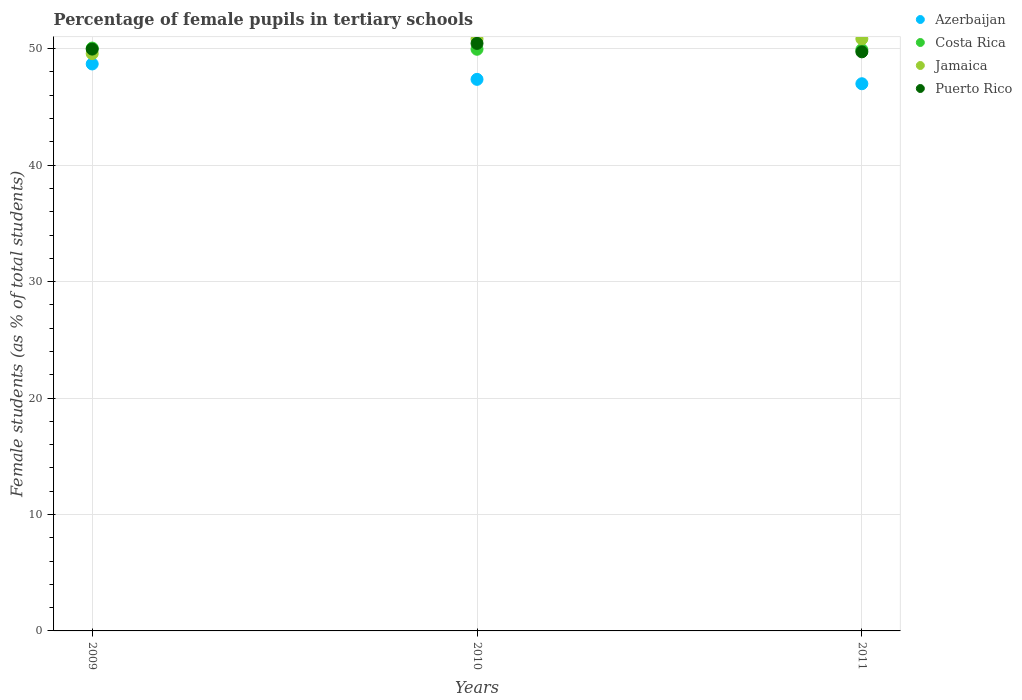What is the percentage of female pupils in tertiary schools in Costa Rica in 2011?
Your answer should be very brief. 49.91. Across all years, what is the maximum percentage of female pupils in tertiary schools in Puerto Rico?
Keep it short and to the point. 50.45. Across all years, what is the minimum percentage of female pupils in tertiary schools in Azerbaijan?
Offer a very short reply. 46.99. In which year was the percentage of female pupils in tertiary schools in Costa Rica maximum?
Your answer should be compact. 2009. In which year was the percentage of female pupils in tertiary schools in Puerto Rico minimum?
Provide a short and direct response. 2011. What is the total percentage of female pupils in tertiary schools in Costa Rica in the graph?
Make the answer very short. 149.92. What is the difference between the percentage of female pupils in tertiary schools in Azerbaijan in 2009 and that in 2010?
Ensure brevity in your answer.  1.32. What is the difference between the percentage of female pupils in tertiary schools in Azerbaijan in 2011 and the percentage of female pupils in tertiary schools in Costa Rica in 2009?
Make the answer very short. -3.06. What is the average percentage of female pupils in tertiary schools in Costa Rica per year?
Your answer should be very brief. 49.97. In the year 2010, what is the difference between the percentage of female pupils in tertiary schools in Azerbaijan and percentage of female pupils in tertiary schools in Jamaica?
Make the answer very short. -3.47. What is the ratio of the percentage of female pupils in tertiary schools in Puerto Rico in 2010 to that in 2011?
Keep it short and to the point. 1.01. Is the percentage of female pupils in tertiary schools in Jamaica in 2009 less than that in 2011?
Your answer should be compact. Yes. Is the difference between the percentage of female pupils in tertiary schools in Azerbaijan in 2009 and 2010 greater than the difference between the percentage of female pupils in tertiary schools in Jamaica in 2009 and 2010?
Keep it short and to the point. Yes. What is the difference between the highest and the second highest percentage of female pupils in tertiary schools in Puerto Rico?
Keep it short and to the point. 0.49. What is the difference between the highest and the lowest percentage of female pupils in tertiary schools in Costa Rica?
Provide a short and direct response. 0.14. Is the percentage of female pupils in tertiary schools in Jamaica strictly less than the percentage of female pupils in tertiary schools in Costa Rica over the years?
Give a very brief answer. No. How many years are there in the graph?
Your answer should be compact. 3. What is the difference between two consecutive major ticks on the Y-axis?
Provide a short and direct response. 10. Does the graph contain grids?
Provide a short and direct response. Yes. What is the title of the graph?
Provide a short and direct response. Percentage of female pupils in tertiary schools. What is the label or title of the Y-axis?
Your response must be concise. Female students (as % of total students). What is the Female students (as % of total students) in Azerbaijan in 2009?
Give a very brief answer. 48.69. What is the Female students (as % of total students) of Costa Rica in 2009?
Your answer should be compact. 50.05. What is the Female students (as % of total students) of Jamaica in 2009?
Offer a terse response. 49.58. What is the Female students (as % of total students) in Puerto Rico in 2009?
Offer a terse response. 49.97. What is the Female students (as % of total students) of Azerbaijan in 2010?
Give a very brief answer. 47.37. What is the Female students (as % of total students) in Costa Rica in 2010?
Keep it short and to the point. 49.95. What is the Female students (as % of total students) in Jamaica in 2010?
Your response must be concise. 50.84. What is the Female students (as % of total students) in Puerto Rico in 2010?
Your response must be concise. 50.45. What is the Female students (as % of total students) in Azerbaijan in 2011?
Offer a very short reply. 46.99. What is the Female students (as % of total students) of Costa Rica in 2011?
Ensure brevity in your answer.  49.91. What is the Female students (as % of total students) in Jamaica in 2011?
Make the answer very short. 50.85. What is the Female students (as % of total students) in Puerto Rico in 2011?
Offer a very short reply. 49.73. Across all years, what is the maximum Female students (as % of total students) of Azerbaijan?
Provide a succinct answer. 48.69. Across all years, what is the maximum Female students (as % of total students) of Costa Rica?
Your answer should be compact. 50.05. Across all years, what is the maximum Female students (as % of total students) of Jamaica?
Offer a very short reply. 50.85. Across all years, what is the maximum Female students (as % of total students) in Puerto Rico?
Your response must be concise. 50.45. Across all years, what is the minimum Female students (as % of total students) of Azerbaijan?
Your answer should be compact. 46.99. Across all years, what is the minimum Female students (as % of total students) of Costa Rica?
Provide a succinct answer. 49.91. Across all years, what is the minimum Female students (as % of total students) of Jamaica?
Give a very brief answer. 49.58. Across all years, what is the minimum Female students (as % of total students) of Puerto Rico?
Offer a terse response. 49.73. What is the total Female students (as % of total students) in Azerbaijan in the graph?
Your response must be concise. 143.05. What is the total Female students (as % of total students) of Costa Rica in the graph?
Your response must be concise. 149.92. What is the total Female students (as % of total students) of Jamaica in the graph?
Ensure brevity in your answer.  151.27. What is the total Female students (as % of total students) of Puerto Rico in the graph?
Provide a succinct answer. 150.15. What is the difference between the Female students (as % of total students) of Azerbaijan in 2009 and that in 2010?
Provide a short and direct response. 1.32. What is the difference between the Female students (as % of total students) of Costa Rica in 2009 and that in 2010?
Your response must be concise. 0.1. What is the difference between the Female students (as % of total students) in Jamaica in 2009 and that in 2010?
Your answer should be compact. -1.26. What is the difference between the Female students (as % of total students) of Puerto Rico in 2009 and that in 2010?
Provide a succinct answer. -0.49. What is the difference between the Female students (as % of total students) in Azerbaijan in 2009 and that in 2011?
Give a very brief answer. 1.7. What is the difference between the Female students (as % of total students) in Costa Rica in 2009 and that in 2011?
Offer a terse response. 0.14. What is the difference between the Female students (as % of total students) of Jamaica in 2009 and that in 2011?
Your response must be concise. -1.27. What is the difference between the Female students (as % of total students) of Puerto Rico in 2009 and that in 2011?
Your answer should be compact. 0.24. What is the difference between the Female students (as % of total students) of Azerbaijan in 2010 and that in 2011?
Your response must be concise. 0.38. What is the difference between the Female students (as % of total students) in Costa Rica in 2010 and that in 2011?
Make the answer very short. 0.04. What is the difference between the Female students (as % of total students) of Jamaica in 2010 and that in 2011?
Provide a succinct answer. -0.01. What is the difference between the Female students (as % of total students) of Puerto Rico in 2010 and that in 2011?
Give a very brief answer. 0.72. What is the difference between the Female students (as % of total students) in Azerbaijan in 2009 and the Female students (as % of total students) in Costa Rica in 2010?
Ensure brevity in your answer.  -1.26. What is the difference between the Female students (as % of total students) of Azerbaijan in 2009 and the Female students (as % of total students) of Jamaica in 2010?
Ensure brevity in your answer.  -2.15. What is the difference between the Female students (as % of total students) of Azerbaijan in 2009 and the Female students (as % of total students) of Puerto Rico in 2010?
Offer a very short reply. -1.77. What is the difference between the Female students (as % of total students) in Costa Rica in 2009 and the Female students (as % of total students) in Jamaica in 2010?
Your answer should be very brief. -0.79. What is the difference between the Female students (as % of total students) in Costa Rica in 2009 and the Female students (as % of total students) in Puerto Rico in 2010?
Your answer should be compact. -0.4. What is the difference between the Female students (as % of total students) of Jamaica in 2009 and the Female students (as % of total students) of Puerto Rico in 2010?
Your answer should be compact. -0.88. What is the difference between the Female students (as % of total students) in Azerbaijan in 2009 and the Female students (as % of total students) in Costa Rica in 2011?
Provide a succinct answer. -1.22. What is the difference between the Female students (as % of total students) in Azerbaijan in 2009 and the Female students (as % of total students) in Jamaica in 2011?
Ensure brevity in your answer.  -2.16. What is the difference between the Female students (as % of total students) in Azerbaijan in 2009 and the Female students (as % of total students) in Puerto Rico in 2011?
Keep it short and to the point. -1.04. What is the difference between the Female students (as % of total students) of Costa Rica in 2009 and the Female students (as % of total students) of Jamaica in 2011?
Your response must be concise. -0.79. What is the difference between the Female students (as % of total students) of Costa Rica in 2009 and the Female students (as % of total students) of Puerto Rico in 2011?
Keep it short and to the point. 0.32. What is the difference between the Female students (as % of total students) in Jamaica in 2009 and the Female students (as % of total students) in Puerto Rico in 2011?
Your answer should be compact. -0.15. What is the difference between the Female students (as % of total students) of Azerbaijan in 2010 and the Female students (as % of total students) of Costa Rica in 2011?
Your answer should be compact. -2.54. What is the difference between the Female students (as % of total students) of Azerbaijan in 2010 and the Female students (as % of total students) of Jamaica in 2011?
Your answer should be compact. -3.48. What is the difference between the Female students (as % of total students) of Azerbaijan in 2010 and the Female students (as % of total students) of Puerto Rico in 2011?
Make the answer very short. -2.36. What is the difference between the Female students (as % of total students) of Costa Rica in 2010 and the Female students (as % of total students) of Jamaica in 2011?
Provide a succinct answer. -0.9. What is the difference between the Female students (as % of total students) in Costa Rica in 2010 and the Female students (as % of total students) in Puerto Rico in 2011?
Offer a terse response. 0.22. What is the difference between the Female students (as % of total students) of Jamaica in 2010 and the Female students (as % of total students) of Puerto Rico in 2011?
Make the answer very short. 1.11. What is the average Female students (as % of total students) in Azerbaijan per year?
Keep it short and to the point. 47.68. What is the average Female students (as % of total students) in Costa Rica per year?
Your answer should be very brief. 49.97. What is the average Female students (as % of total students) of Jamaica per year?
Ensure brevity in your answer.  50.42. What is the average Female students (as % of total students) of Puerto Rico per year?
Make the answer very short. 50.05. In the year 2009, what is the difference between the Female students (as % of total students) in Azerbaijan and Female students (as % of total students) in Costa Rica?
Make the answer very short. -1.36. In the year 2009, what is the difference between the Female students (as % of total students) in Azerbaijan and Female students (as % of total students) in Jamaica?
Keep it short and to the point. -0.89. In the year 2009, what is the difference between the Female students (as % of total students) in Azerbaijan and Female students (as % of total students) in Puerto Rico?
Your answer should be compact. -1.28. In the year 2009, what is the difference between the Female students (as % of total students) of Costa Rica and Female students (as % of total students) of Jamaica?
Provide a short and direct response. 0.47. In the year 2009, what is the difference between the Female students (as % of total students) of Costa Rica and Female students (as % of total students) of Puerto Rico?
Keep it short and to the point. 0.09. In the year 2009, what is the difference between the Female students (as % of total students) in Jamaica and Female students (as % of total students) in Puerto Rico?
Offer a terse response. -0.39. In the year 2010, what is the difference between the Female students (as % of total students) of Azerbaijan and Female students (as % of total students) of Costa Rica?
Your answer should be compact. -2.58. In the year 2010, what is the difference between the Female students (as % of total students) of Azerbaijan and Female students (as % of total students) of Jamaica?
Your answer should be very brief. -3.47. In the year 2010, what is the difference between the Female students (as % of total students) of Azerbaijan and Female students (as % of total students) of Puerto Rico?
Provide a short and direct response. -3.09. In the year 2010, what is the difference between the Female students (as % of total students) of Costa Rica and Female students (as % of total students) of Jamaica?
Your answer should be compact. -0.89. In the year 2010, what is the difference between the Female students (as % of total students) of Costa Rica and Female students (as % of total students) of Puerto Rico?
Your response must be concise. -0.5. In the year 2010, what is the difference between the Female students (as % of total students) of Jamaica and Female students (as % of total students) of Puerto Rico?
Ensure brevity in your answer.  0.38. In the year 2011, what is the difference between the Female students (as % of total students) of Azerbaijan and Female students (as % of total students) of Costa Rica?
Make the answer very short. -2.92. In the year 2011, what is the difference between the Female students (as % of total students) of Azerbaijan and Female students (as % of total students) of Jamaica?
Provide a short and direct response. -3.86. In the year 2011, what is the difference between the Female students (as % of total students) of Azerbaijan and Female students (as % of total students) of Puerto Rico?
Make the answer very short. -2.74. In the year 2011, what is the difference between the Female students (as % of total students) in Costa Rica and Female students (as % of total students) in Jamaica?
Give a very brief answer. -0.94. In the year 2011, what is the difference between the Female students (as % of total students) of Costa Rica and Female students (as % of total students) of Puerto Rico?
Provide a short and direct response. 0.18. In the year 2011, what is the difference between the Female students (as % of total students) in Jamaica and Female students (as % of total students) in Puerto Rico?
Keep it short and to the point. 1.12. What is the ratio of the Female students (as % of total students) in Azerbaijan in 2009 to that in 2010?
Offer a terse response. 1.03. What is the ratio of the Female students (as % of total students) in Jamaica in 2009 to that in 2010?
Your answer should be very brief. 0.98. What is the ratio of the Female students (as % of total students) of Puerto Rico in 2009 to that in 2010?
Ensure brevity in your answer.  0.99. What is the ratio of the Female students (as % of total students) of Azerbaijan in 2009 to that in 2011?
Give a very brief answer. 1.04. What is the ratio of the Female students (as % of total students) in Costa Rica in 2009 to that in 2011?
Provide a succinct answer. 1. What is the ratio of the Female students (as % of total students) in Jamaica in 2009 to that in 2011?
Make the answer very short. 0.97. What is the ratio of the Female students (as % of total students) in Puerto Rico in 2009 to that in 2011?
Your response must be concise. 1. What is the ratio of the Female students (as % of total students) of Costa Rica in 2010 to that in 2011?
Offer a terse response. 1. What is the ratio of the Female students (as % of total students) in Jamaica in 2010 to that in 2011?
Provide a short and direct response. 1. What is the ratio of the Female students (as % of total students) in Puerto Rico in 2010 to that in 2011?
Your answer should be very brief. 1.01. What is the difference between the highest and the second highest Female students (as % of total students) in Azerbaijan?
Keep it short and to the point. 1.32. What is the difference between the highest and the second highest Female students (as % of total students) of Costa Rica?
Your response must be concise. 0.1. What is the difference between the highest and the second highest Female students (as % of total students) of Jamaica?
Ensure brevity in your answer.  0.01. What is the difference between the highest and the second highest Female students (as % of total students) in Puerto Rico?
Your response must be concise. 0.49. What is the difference between the highest and the lowest Female students (as % of total students) in Azerbaijan?
Your response must be concise. 1.7. What is the difference between the highest and the lowest Female students (as % of total students) in Costa Rica?
Your response must be concise. 0.14. What is the difference between the highest and the lowest Female students (as % of total students) in Jamaica?
Your answer should be very brief. 1.27. What is the difference between the highest and the lowest Female students (as % of total students) of Puerto Rico?
Give a very brief answer. 0.72. 